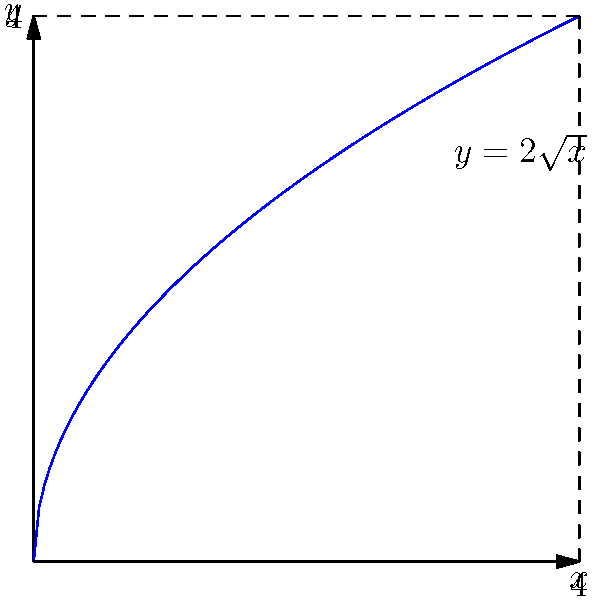As an aid worker, you need to calculate the volume of a cylindrical water tank for a refugee camp. The tank has a radius of 2 meters and a height of 4 meters. The water level in the tank is described by the function $y = 2\sqrt{x}$, where $x$ is the distance from the center of the base (in meters) and $y$ is the height of the water (in meters). Calculate the volume of water in the tank using integration techniques. To solve this problem, we'll use the method of cylindrical shells:

1) The volume of a cylindrical shell is given by $dV = 2\pi x y dx$, where $x$ is the radius of the shell and $y$ is its height.

2) We're given that $y = 2\sqrt{x}$, so we substitute this into our volume element:
   $dV = 2\pi x (2\sqrt{x}) dx = 4\pi x\sqrt{x} dx$

3) The limits of integration are from $x = 0$ (center of the base) to $x = 4$ (edge of the tank).

4) Set up the integral:
   $V = \int_0^4 4\pi x\sqrt{x} dx$

5) Simplify the integrand:
   $V = 4\pi \int_0^4 x^{3/2} dx$

6) Integrate:
   $V = 4\pi [\frac{2}{5}x^{5/2}]_0^4$

7) Evaluate the integral:
   $V = 4\pi [\frac{2}{5}(4^{5/2}) - \frac{2}{5}(0^{5/2})]$
   $V = 4\pi [\frac{2}{5}(32)]$
   $V = \frac{256\pi}{5}$

8) This is in cubic meters. To get a more precise value, we can calculate:
   $V \approx 160.85$ cubic meters

Therefore, the volume of water in the tank is approximately 160.85 cubic meters.
Answer: $\frac{256\pi}{5}$ m³ or approximately 160.85 m³ 